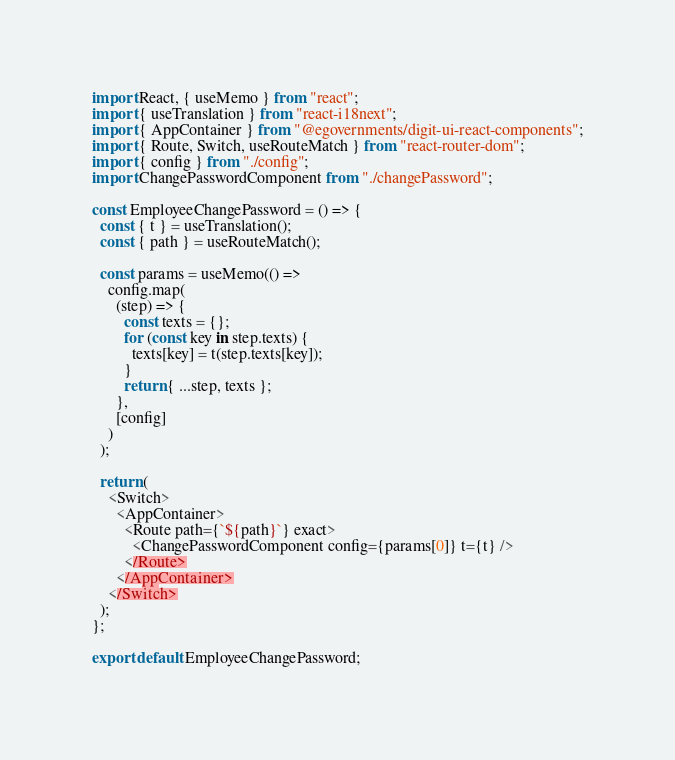Convert code to text. <code><loc_0><loc_0><loc_500><loc_500><_JavaScript_>import React, { useMemo } from "react";
import { useTranslation } from "react-i18next";
import { AppContainer } from "@egovernments/digit-ui-react-components";
import { Route, Switch, useRouteMatch } from "react-router-dom";
import { config } from "./config";
import ChangePasswordComponent from "./changePassword";

const EmployeeChangePassword = () => {
  const { t } = useTranslation();
  const { path } = useRouteMatch();

  const params = useMemo(() =>
    config.map(
      (step) => {
        const texts = {};
        for (const key in step.texts) {
          texts[key] = t(step.texts[key]);
        }
        return { ...step, texts };
      },
      [config]
    )
  );

  return (
    <Switch>
      <AppContainer>
        <Route path={`${path}`} exact>
          <ChangePasswordComponent config={params[0]} t={t} />
        </Route>
      </AppContainer>
    </Switch>
  );
};

export default EmployeeChangePassword;
</code> 